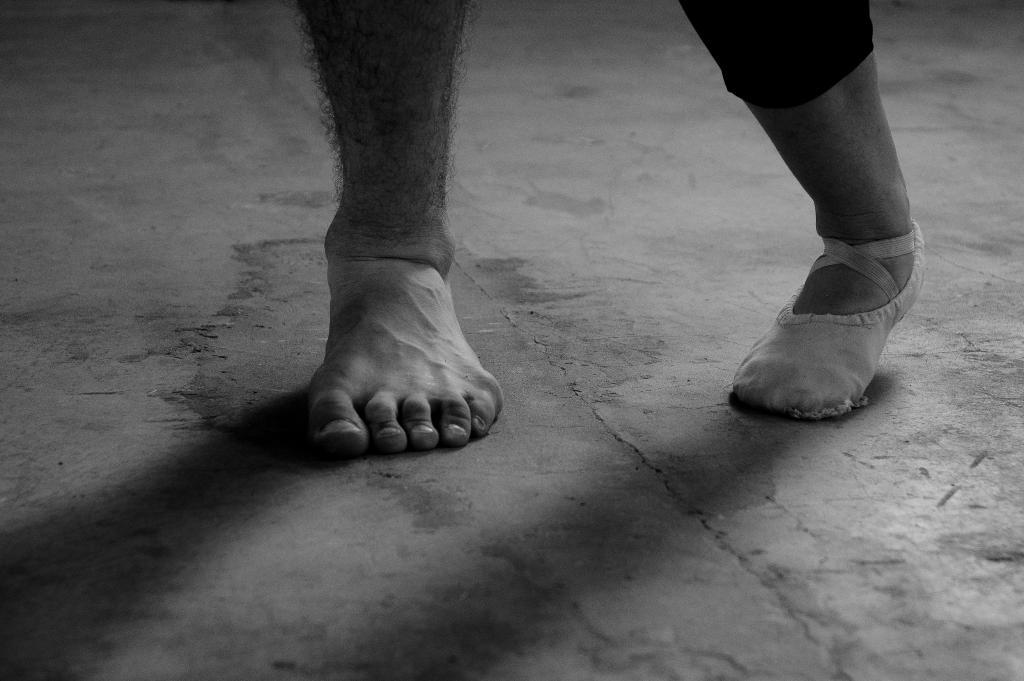What can be seen in the image related to people? There are legs of two people visible in the image. Where are the legs located? The legs are on the ground. What thoughts are the legs having in the image? Legs do not have thoughts, as they are a part of the human body and not capable of thinking. 